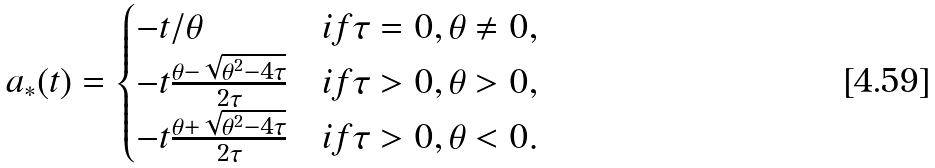<formula> <loc_0><loc_0><loc_500><loc_500>a _ { * } ( t ) = \begin{cases} - t / \theta & i f \tau = 0 , \theta \ne 0 , \\ - t \frac { \theta - \sqrt { \theta ^ { 2 } - 4 \tau } } { 2 \tau } & i f \tau > 0 , \theta > 0 , \\ - t \frac { \theta + \sqrt { \theta ^ { 2 } - 4 \tau } } { 2 \tau } & i f \tau > 0 , \theta < 0 . \end{cases}</formula> 